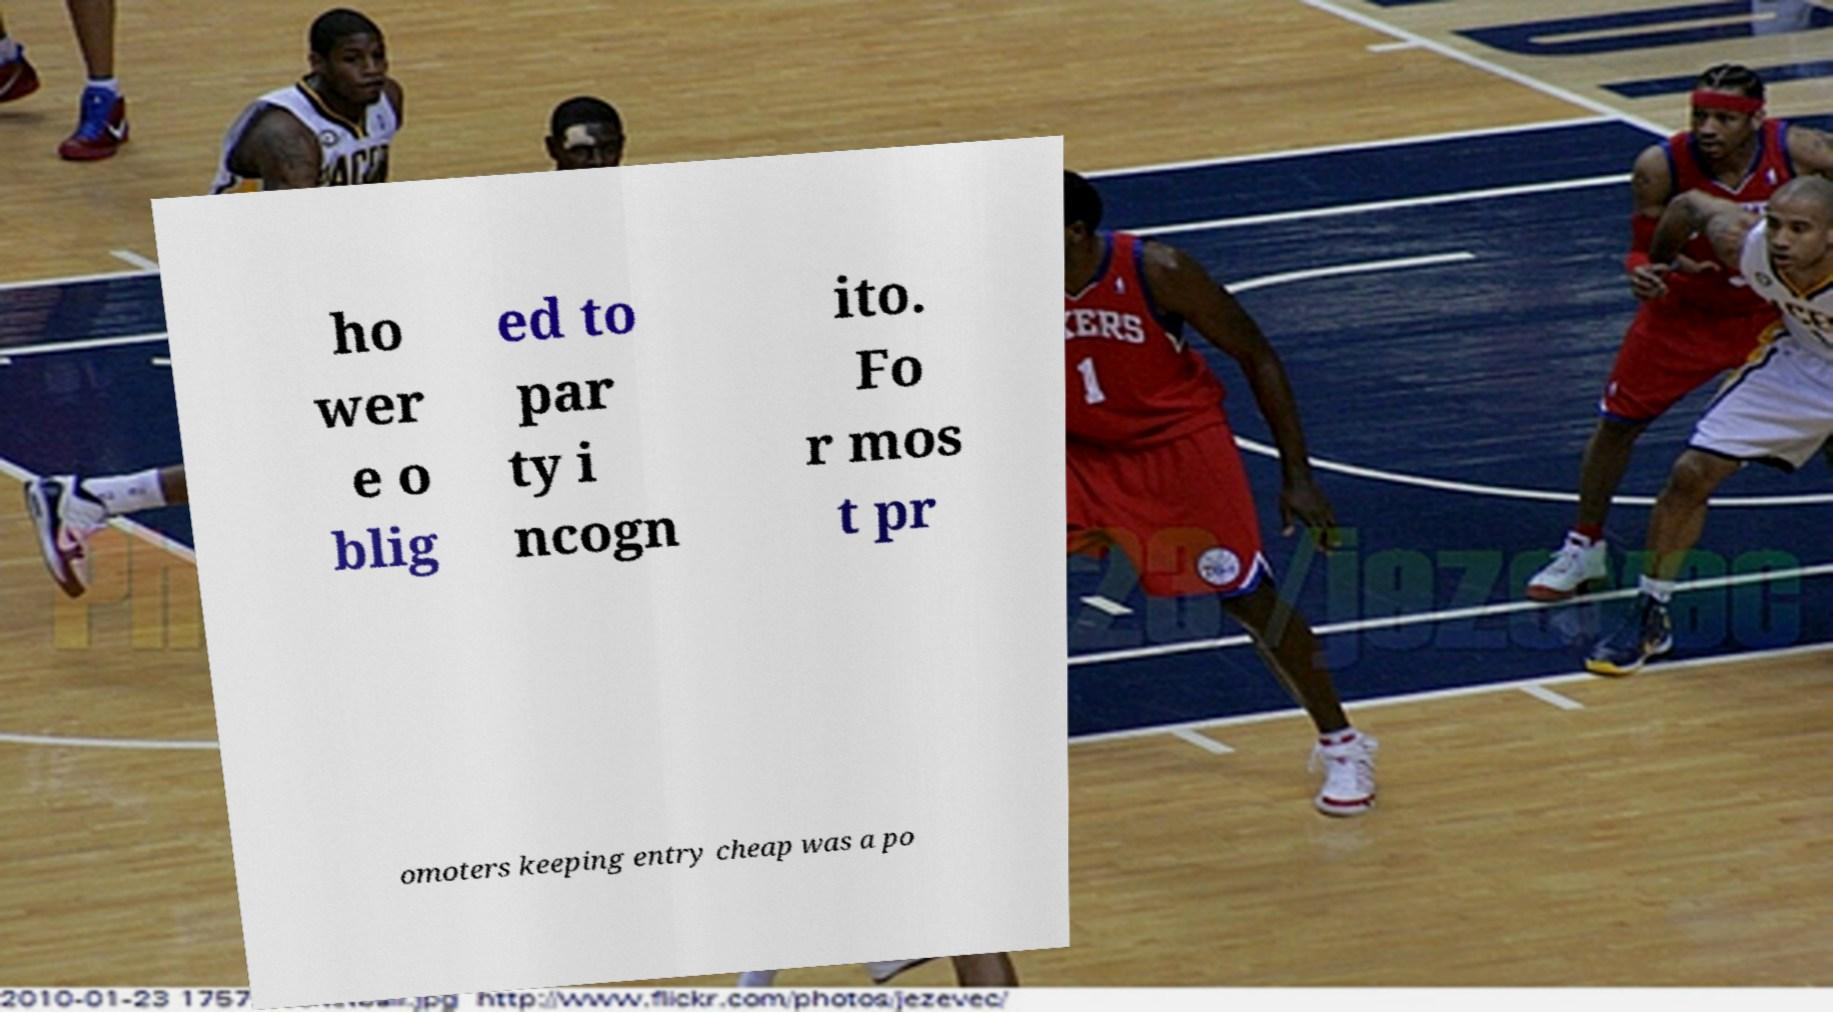For documentation purposes, I need the text within this image transcribed. Could you provide that? ho wer e o blig ed to par ty i ncogn ito. Fo r mos t pr omoters keeping entry cheap was a po 